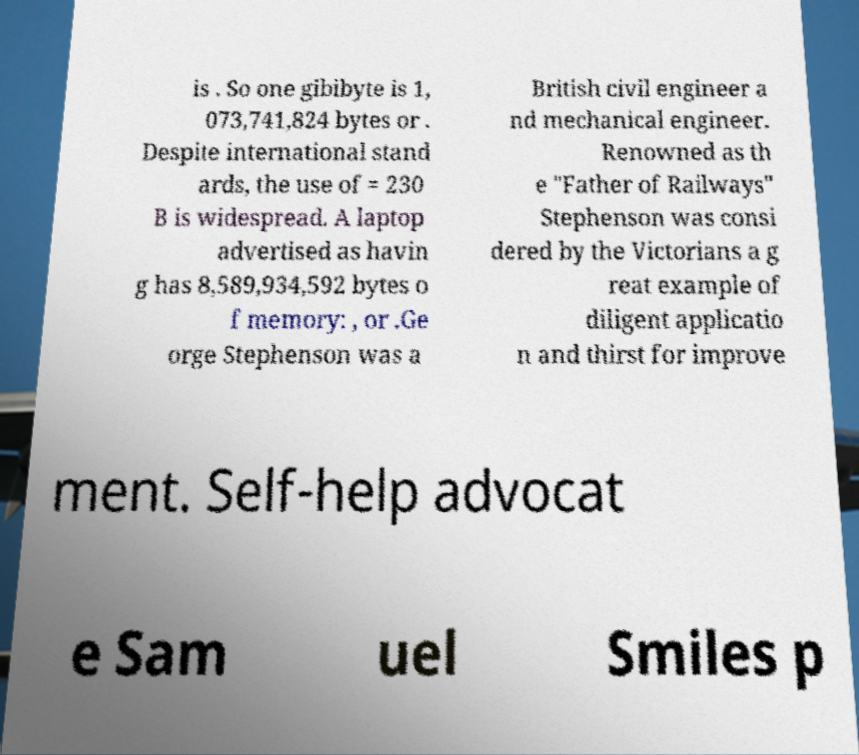Could you extract and type out the text from this image? is . So one gibibyte is 1, 073,741,824 bytes or . Despite international stand ards, the use of = 230 B is widespread. A laptop advertised as havin g has 8,589,934,592 bytes o f memory: , or .Ge orge Stephenson was a British civil engineer a nd mechanical engineer. Renowned as th e "Father of Railways" Stephenson was consi dered by the Victorians a g reat example of diligent applicatio n and thirst for improve ment. Self-help advocat e Sam uel Smiles p 